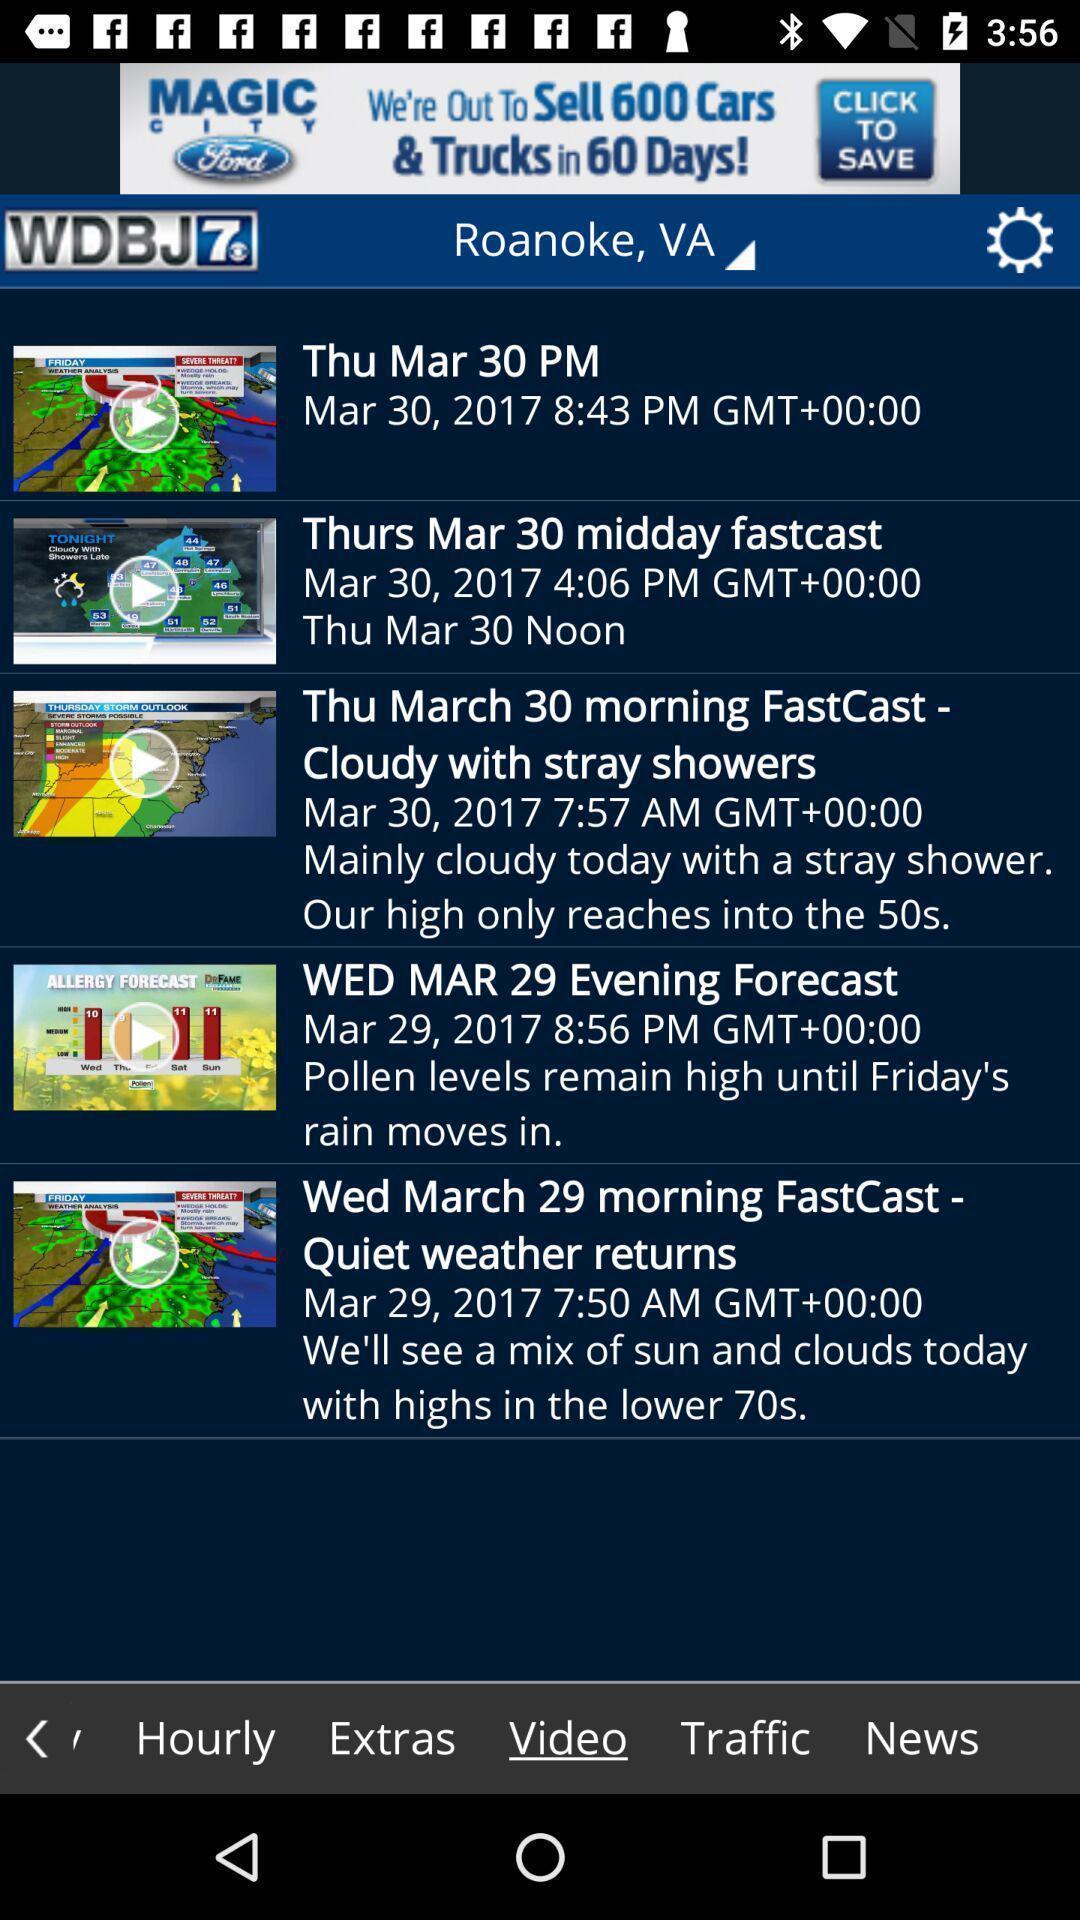Summarize the information in this screenshot. Weather application displayed different videos of weather condition. 